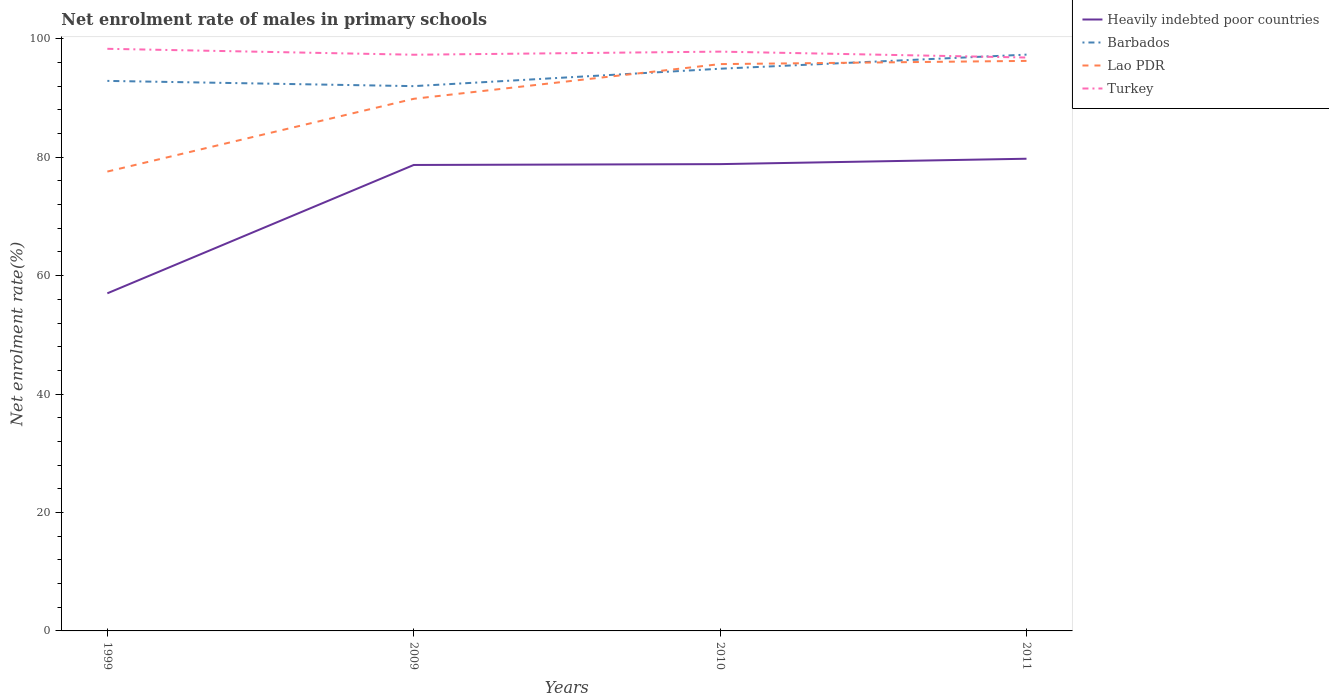How many different coloured lines are there?
Give a very brief answer. 4. Is the number of lines equal to the number of legend labels?
Your response must be concise. Yes. Across all years, what is the maximum net enrolment rate of males in primary schools in Lao PDR?
Provide a short and direct response. 77.58. What is the total net enrolment rate of males in primary schools in Heavily indebted poor countries in the graph?
Offer a terse response. -21.68. What is the difference between the highest and the second highest net enrolment rate of males in primary schools in Lao PDR?
Offer a terse response. 18.69. What is the difference between the highest and the lowest net enrolment rate of males in primary schools in Heavily indebted poor countries?
Offer a terse response. 3. Is the net enrolment rate of males in primary schools in Heavily indebted poor countries strictly greater than the net enrolment rate of males in primary schools in Barbados over the years?
Offer a terse response. Yes. How many lines are there?
Ensure brevity in your answer.  4. How many years are there in the graph?
Offer a terse response. 4. What is the difference between two consecutive major ticks on the Y-axis?
Offer a terse response. 20. Does the graph contain any zero values?
Offer a very short reply. No. Does the graph contain grids?
Provide a short and direct response. No. Where does the legend appear in the graph?
Ensure brevity in your answer.  Top right. How many legend labels are there?
Keep it short and to the point. 4. How are the legend labels stacked?
Offer a very short reply. Vertical. What is the title of the graph?
Provide a short and direct response. Net enrolment rate of males in primary schools. What is the label or title of the X-axis?
Provide a short and direct response. Years. What is the label or title of the Y-axis?
Your response must be concise. Net enrolment rate(%). What is the Net enrolment rate(%) in Heavily indebted poor countries in 1999?
Offer a terse response. 57.02. What is the Net enrolment rate(%) in Barbados in 1999?
Keep it short and to the point. 92.9. What is the Net enrolment rate(%) of Lao PDR in 1999?
Your response must be concise. 77.58. What is the Net enrolment rate(%) of Turkey in 1999?
Your answer should be compact. 98.32. What is the Net enrolment rate(%) in Heavily indebted poor countries in 2009?
Make the answer very short. 78.7. What is the Net enrolment rate(%) of Barbados in 2009?
Provide a succinct answer. 92.01. What is the Net enrolment rate(%) in Lao PDR in 2009?
Make the answer very short. 89.87. What is the Net enrolment rate(%) of Turkey in 2009?
Offer a terse response. 97.31. What is the Net enrolment rate(%) of Heavily indebted poor countries in 2010?
Ensure brevity in your answer.  78.84. What is the Net enrolment rate(%) in Barbados in 2010?
Ensure brevity in your answer.  94.95. What is the Net enrolment rate(%) in Lao PDR in 2010?
Your answer should be very brief. 95.73. What is the Net enrolment rate(%) in Turkey in 2010?
Give a very brief answer. 97.84. What is the Net enrolment rate(%) in Heavily indebted poor countries in 2011?
Your answer should be compact. 79.75. What is the Net enrolment rate(%) in Barbados in 2011?
Your answer should be very brief. 97.33. What is the Net enrolment rate(%) in Lao PDR in 2011?
Provide a succinct answer. 96.27. What is the Net enrolment rate(%) of Turkey in 2011?
Your answer should be compact. 96.84. Across all years, what is the maximum Net enrolment rate(%) in Heavily indebted poor countries?
Ensure brevity in your answer.  79.75. Across all years, what is the maximum Net enrolment rate(%) in Barbados?
Your answer should be very brief. 97.33. Across all years, what is the maximum Net enrolment rate(%) in Lao PDR?
Keep it short and to the point. 96.27. Across all years, what is the maximum Net enrolment rate(%) in Turkey?
Your response must be concise. 98.32. Across all years, what is the minimum Net enrolment rate(%) in Heavily indebted poor countries?
Give a very brief answer. 57.02. Across all years, what is the minimum Net enrolment rate(%) in Barbados?
Make the answer very short. 92.01. Across all years, what is the minimum Net enrolment rate(%) in Lao PDR?
Offer a terse response. 77.58. Across all years, what is the minimum Net enrolment rate(%) in Turkey?
Make the answer very short. 96.84. What is the total Net enrolment rate(%) of Heavily indebted poor countries in the graph?
Provide a short and direct response. 294.3. What is the total Net enrolment rate(%) in Barbados in the graph?
Offer a terse response. 377.19. What is the total Net enrolment rate(%) of Lao PDR in the graph?
Offer a very short reply. 359.46. What is the total Net enrolment rate(%) of Turkey in the graph?
Offer a terse response. 390.31. What is the difference between the Net enrolment rate(%) of Heavily indebted poor countries in 1999 and that in 2009?
Your answer should be compact. -21.68. What is the difference between the Net enrolment rate(%) in Barbados in 1999 and that in 2009?
Give a very brief answer. 0.89. What is the difference between the Net enrolment rate(%) of Lao PDR in 1999 and that in 2009?
Provide a succinct answer. -12.29. What is the difference between the Net enrolment rate(%) of Heavily indebted poor countries in 1999 and that in 2010?
Your answer should be very brief. -21.82. What is the difference between the Net enrolment rate(%) of Barbados in 1999 and that in 2010?
Provide a short and direct response. -2.05. What is the difference between the Net enrolment rate(%) of Lao PDR in 1999 and that in 2010?
Provide a short and direct response. -18.15. What is the difference between the Net enrolment rate(%) of Turkey in 1999 and that in 2010?
Provide a short and direct response. 0.48. What is the difference between the Net enrolment rate(%) in Heavily indebted poor countries in 1999 and that in 2011?
Your answer should be very brief. -22.73. What is the difference between the Net enrolment rate(%) in Barbados in 1999 and that in 2011?
Keep it short and to the point. -4.44. What is the difference between the Net enrolment rate(%) of Lao PDR in 1999 and that in 2011?
Your answer should be very brief. -18.69. What is the difference between the Net enrolment rate(%) of Turkey in 1999 and that in 2011?
Keep it short and to the point. 1.47. What is the difference between the Net enrolment rate(%) in Heavily indebted poor countries in 2009 and that in 2010?
Keep it short and to the point. -0.14. What is the difference between the Net enrolment rate(%) in Barbados in 2009 and that in 2010?
Make the answer very short. -2.94. What is the difference between the Net enrolment rate(%) in Lao PDR in 2009 and that in 2010?
Your answer should be very brief. -5.86. What is the difference between the Net enrolment rate(%) of Turkey in 2009 and that in 2010?
Offer a very short reply. -0.53. What is the difference between the Net enrolment rate(%) in Heavily indebted poor countries in 2009 and that in 2011?
Your answer should be compact. -1.05. What is the difference between the Net enrolment rate(%) in Barbados in 2009 and that in 2011?
Offer a terse response. -5.32. What is the difference between the Net enrolment rate(%) in Lao PDR in 2009 and that in 2011?
Your answer should be compact. -6.4. What is the difference between the Net enrolment rate(%) of Turkey in 2009 and that in 2011?
Give a very brief answer. 0.47. What is the difference between the Net enrolment rate(%) of Heavily indebted poor countries in 2010 and that in 2011?
Your answer should be compact. -0.91. What is the difference between the Net enrolment rate(%) in Barbados in 2010 and that in 2011?
Offer a terse response. -2.38. What is the difference between the Net enrolment rate(%) in Lao PDR in 2010 and that in 2011?
Provide a succinct answer. -0.54. What is the difference between the Net enrolment rate(%) of Turkey in 2010 and that in 2011?
Make the answer very short. 1. What is the difference between the Net enrolment rate(%) of Heavily indebted poor countries in 1999 and the Net enrolment rate(%) of Barbados in 2009?
Provide a succinct answer. -34.99. What is the difference between the Net enrolment rate(%) in Heavily indebted poor countries in 1999 and the Net enrolment rate(%) in Lao PDR in 2009?
Offer a terse response. -32.85. What is the difference between the Net enrolment rate(%) in Heavily indebted poor countries in 1999 and the Net enrolment rate(%) in Turkey in 2009?
Keep it short and to the point. -40.3. What is the difference between the Net enrolment rate(%) in Barbados in 1999 and the Net enrolment rate(%) in Lao PDR in 2009?
Provide a succinct answer. 3.03. What is the difference between the Net enrolment rate(%) in Barbados in 1999 and the Net enrolment rate(%) in Turkey in 2009?
Offer a very short reply. -4.42. What is the difference between the Net enrolment rate(%) in Lao PDR in 1999 and the Net enrolment rate(%) in Turkey in 2009?
Give a very brief answer. -19.73. What is the difference between the Net enrolment rate(%) of Heavily indebted poor countries in 1999 and the Net enrolment rate(%) of Barbados in 2010?
Provide a succinct answer. -37.93. What is the difference between the Net enrolment rate(%) of Heavily indebted poor countries in 1999 and the Net enrolment rate(%) of Lao PDR in 2010?
Keep it short and to the point. -38.71. What is the difference between the Net enrolment rate(%) of Heavily indebted poor countries in 1999 and the Net enrolment rate(%) of Turkey in 2010?
Keep it short and to the point. -40.82. What is the difference between the Net enrolment rate(%) of Barbados in 1999 and the Net enrolment rate(%) of Lao PDR in 2010?
Ensure brevity in your answer.  -2.84. What is the difference between the Net enrolment rate(%) of Barbados in 1999 and the Net enrolment rate(%) of Turkey in 2010?
Make the answer very short. -4.94. What is the difference between the Net enrolment rate(%) of Lao PDR in 1999 and the Net enrolment rate(%) of Turkey in 2010?
Give a very brief answer. -20.26. What is the difference between the Net enrolment rate(%) of Heavily indebted poor countries in 1999 and the Net enrolment rate(%) of Barbados in 2011?
Make the answer very short. -40.31. What is the difference between the Net enrolment rate(%) in Heavily indebted poor countries in 1999 and the Net enrolment rate(%) in Lao PDR in 2011?
Offer a very short reply. -39.25. What is the difference between the Net enrolment rate(%) of Heavily indebted poor countries in 1999 and the Net enrolment rate(%) of Turkey in 2011?
Keep it short and to the point. -39.82. What is the difference between the Net enrolment rate(%) in Barbados in 1999 and the Net enrolment rate(%) in Lao PDR in 2011?
Provide a short and direct response. -3.38. What is the difference between the Net enrolment rate(%) of Barbados in 1999 and the Net enrolment rate(%) of Turkey in 2011?
Offer a terse response. -3.95. What is the difference between the Net enrolment rate(%) in Lao PDR in 1999 and the Net enrolment rate(%) in Turkey in 2011?
Provide a short and direct response. -19.26. What is the difference between the Net enrolment rate(%) in Heavily indebted poor countries in 2009 and the Net enrolment rate(%) in Barbados in 2010?
Your answer should be compact. -16.25. What is the difference between the Net enrolment rate(%) in Heavily indebted poor countries in 2009 and the Net enrolment rate(%) in Lao PDR in 2010?
Provide a short and direct response. -17.04. What is the difference between the Net enrolment rate(%) of Heavily indebted poor countries in 2009 and the Net enrolment rate(%) of Turkey in 2010?
Your response must be concise. -19.14. What is the difference between the Net enrolment rate(%) in Barbados in 2009 and the Net enrolment rate(%) in Lao PDR in 2010?
Offer a terse response. -3.72. What is the difference between the Net enrolment rate(%) of Barbados in 2009 and the Net enrolment rate(%) of Turkey in 2010?
Make the answer very short. -5.83. What is the difference between the Net enrolment rate(%) in Lao PDR in 2009 and the Net enrolment rate(%) in Turkey in 2010?
Your answer should be very brief. -7.97. What is the difference between the Net enrolment rate(%) in Heavily indebted poor countries in 2009 and the Net enrolment rate(%) in Barbados in 2011?
Give a very brief answer. -18.64. What is the difference between the Net enrolment rate(%) of Heavily indebted poor countries in 2009 and the Net enrolment rate(%) of Lao PDR in 2011?
Provide a short and direct response. -17.58. What is the difference between the Net enrolment rate(%) in Heavily indebted poor countries in 2009 and the Net enrolment rate(%) in Turkey in 2011?
Provide a short and direct response. -18.15. What is the difference between the Net enrolment rate(%) in Barbados in 2009 and the Net enrolment rate(%) in Lao PDR in 2011?
Provide a succinct answer. -4.26. What is the difference between the Net enrolment rate(%) of Barbados in 2009 and the Net enrolment rate(%) of Turkey in 2011?
Offer a very short reply. -4.83. What is the difference between the Net enrolment rate(%) of Lao PDR in 2009 and the Net enrolment rate(%) of Turkey in 2011?
Provide a succinct answer. -6.97. What is the difference between the Net enrolment rate(%) of Heavily indebted poor countries in 2010 and the Net enrolment rate(%) of Barbados in 2011?
Offer a terse response. -18.49. What is the difference between the Net enrolment rate(%) of Heavily indebted poor countries in 2010 and the Net enrolment rate(%) of Lao PDR in 2011?
Provide a short and direct response. -17.43. What is the difference between the Net enrolment rate(%) of Heavily indebted poor countries in 2010 and the Net enrolment rate(%) of Turkey in 2011?
Provide a succinct answer. -18. What is the difference between the Net enrolment rate(%) of Barbados in 2010 and the Net enrolment rate(%) of Lao PDR in 2011?
Your answer should be very brief. -1.32. What is the difference between the Net enrolment rate(%) in Barbados in 2010 and the Net enrolment rate(%) in Turkey in 2011?
Give a very brief answer. -1.89. What is the difference between the Net enrolment rate(%) of Lao PDR in 2010 and the Net enrolment rate(%) of Turkey in 2011?
Your answer should be very brief. -1.11. What is the average Net enrolment rate(%) in Heavily indebted poor countries per year?
Give a very brief answer. 73.58. What is the average Net enrolment rate(%) in Barbados per year?
Offer a very short reply. 94.3. What is the average Net enrolment rate(%) of Lao PDR per year?
Your response must be concise. 89.86. What is the average Net enrolment rate(%) of Turkey per year?
Offer a very short reply. 97.58. In the year 1999, what is the difference between the Net enrolment rate(%) of Heavily indebted poor countries and Net enrolment rate(%) of Barbados?
Make the answer very short. -35.88. In the year 1999, what is the difference between the Net enrolment rate(%) in Heavily indebted poor countries and Net enrolment rate(%) in Lao PDR?
Your response must be concise. -20.56. In the year 1999, what is the difference between the Net enrolment rate(%) in Heavily indebted poor countries and Net enrolment rate(%) in Turkey?
Keep it short and to the point. -41.3. In the year 1999, what is the difference between the Net enrolment rate(%) in Barbados and Net enrolment rate(%) in Lao PDR?
Ensure brevity in your answer.  15.31. In the year 1999, what is the difference between the Net enrolment rate(%) in Barbados and Net enrolment rate(%) in Turkey?
Offer a very short reply. -5.42. In the year 1999, what is the difference between the Net enrolment rate(%) of Lao PDR and Net enrolment rate(%) of Turkey?
Your answer should be very brief. -20.73. In the year 2009, what is the difference between the Net enrolment rate(%) in Heavily indebted poor countries and Net enrolment rate(%) in Barbados?
Provide a short and direct response. -13.31. In the year 2009, what is the difference between the Net enrolment rate(%) in Heavily indebted poor countries and Net enrolment rate(%) in Lao PDR?
Keep it short and to the point. -11.17. In the year 2009, what is the difference between the Net enrolment rate(%) in Heavily indebted poor countries and Net enrolment rate(%) in Turkey?
Offer a terse response. -18.62. In the year 2009, what is the difference between the Net enrolment rate(%) of Barbados and Net enrolment rate(%) of Lao PDR?
Your answer should be very brief. 2.14. In the year 2009, what is the difference between the Net enrolment rate(%) of Barbados and Net enrolment rate(%) of Turkey?
Your answer should be very brief. -5.3. In the year 2009, what is the difference between the Net enrolment rate(%) in Lao PDR and Net enrolment rate(%) in Turkey?
Your response must be concise. -7.44. In the year 2010, what is the difference between the Net enrolment rate(%) of Heavily indebted poor countries and Net enrolment rate(%) of Barbados?
Offer a very short reply. -16.11. In the year 2010, what is the difference between the Net enrolment rate(%) in Heavily indebted poor countries and Net enrolment rate(%) in Lao PDR?
Provide a succinct answer. -16.89. In the year 2010, what is the difference between the Net enrolment rate(%) in Heavily indebted poor countries and Net enrolment rate(%) in Turkey?
Offer a terse response. -19. In the year 2010, what is the difference between the Net enrolment rate(%) in Barbados and Net enrolment rate(%) in Lao PDR?
Your response must be concise. -0.78. In the year 2010, what is the difference between the Net enrolment rate(%) of Barbados and Net enrolment rate(%) of Turkey?
Ensure brevity in your answer.  -2.89. In the year 2010, what is the difference between the Net enrolment rate(%) of Lao PDR and Net enrolment rate(%) of Turkey?
Your response must be concise. -2.11. In the year 2011, what is the difference between the Net enrolment rate(%) in Heavily indebted poor countries and Net enrolment rate(%) in Barbados?
Make the answer very short. -17.58. In the year 2011, what is the difference between the Net enrolment rate(%) of Heavily indebted poor countries and Net enrolment rate(%) of Lao PDR?
Ensure brevity in your answer.  -16.52. In the year 2011, what is the difference between the Net enrolment rate(%) of Heavily indebted poor countries and Net enrolment rate(%) of Turkey?
Offer a terse response. -17.09. In the year 2011, what is the difference between the Net enrolment rate(%) in Barbados and Net enrolment rate(%) in Lao PDR?
Give a very brief answer. 1.06. In the year 2011, what is the difference between the Net enrolment rate(%) in Barbados and Net enrolment rate(%) in Turkey?
Offer a terse response. 0.49. In the year 2011, what is the difference between the Net enrolment rate(%) of Lao PDR and Net enrolment rate(%) of Turkey?
Your answer should be compact. -0.57. What is the ratio of the Net enrolment rate(%) in Heavily indebted poor countries in 1999 to that in 2009?
Provide a short and direct response. 0.72. What is the ratio of the Net enrolment rate(%) of Barbados in 1999 to that in 2009?
Offer a terse response. 1.01. What is the ratio of the Net enrolment rate(%) of Lao PDR in 1999 to that in 2009?
Your answer should be very brief. 0.86. What is the ratio of the Net enrolment rate(%) in Turkey in 1999 to that in 2009?
Ensure brevity in your answer.  1.01. What is the ratio of the Net enrolment rate(%) in Heavily indebted poor countries in 1999 to that in 2010?
Make the answer very short. 0.72. What is the ratio of the Net enrolment rate(%) of Barbados in 1999 to that in 2010?
Provide a short and direct response. 0.98. What is the ratio of the Net enrolment rate(%) in Lao PDR in 1999 to that in 2010?
Ensure brevity in your answer.  0.81. What is the ratio of the Net enrolment rate(%) in Heavily indebted poor countries in 1999 to that in 2011?
Make the answer very short. 0.71. What is the ratio of the Net enrolment rate(%) in Barbados in 1999 to that in 2011?
Provide a succinct answer. 0.95. What is the ratio of the Net enrolment rate(%) in Lao PDR in 1999 to that in 2011?
Provide a short and direct response. 0.81. What is the ratio of the Net enrolment rate(%) of Turkey in 1999 to that in 2011?
Provide a succinct answer. 1.02. What is the ratio of the Net enrolment rate(%) of Barbados in 2009 to that in 2010?
Your response must be concise. 0.97. What is the ratio of the Net enrolment rate(%) in Lao PDR in 2009 to that in 2010?
Give a very brief answer. 0.94. What is the ratio of the Net enrolment rate(%) in Turkey in 2009 to that in 2010?
Your answer should be compact. 0.99. What is the ratio of the Net enrolment rate(%) in Heavily indebted poor countries in 2009 to that in 2011?
Your response must be concise. 0.99. What is the ratio of the Net enrolment rate(%) of Barbados in 2009 to that in 2011?
Your response must be concise. 0.95. What is the ratio of the Net enrolment rate(%) of Lao PDR in 2009 to that in 2011?
Make the answer very short. 0.93. What is the ratio of the Net enrolment rate(%) of Heavily indebted poor countries in 2010 to that in 2011?
Offer a very short reply. 0.99. What is the ratio of the Net enrolment rate(%) of Barbados in 2010 to that in 2011?
Your answer should be compact. 0.98. What is the ratio of the Net enrolment rate(%) of Turkey in 2010 to that in 2011?
Your answer should be very brief. 1.01. What is the difference between the highest and the second highest Net enrolment rate(%) in Heavily indebted poor countries?
Offer a terse response. 0.91. What is the difference between the highest and the second highest Net enrolment rate(%) in Barbados?
Your response must be concise. 2.38. What is the difference between the highest and the second highest Net enrolment rate(%) of Lao PDR?
Give a very brief answer. 0.54. What is the difference between the highest and the second highest Net enrolment rate(%) of Turkey?
Provide a short and direct response. 0.48. What is the difference between the highest and the lowest Net enrolment rate(%) of Heavily indebted poor countries?
Provide a short and direct response. 22.73. What is the difference between the highest and the lowest Net enrolment rate(%) in Barbados?
Your answer should be very brief. 5.32. What is the difference between the highest and the lowest Net enrolment rate(%) of Lao PDR?
Offer a very short reply. 18.69. What is the difference between the highest and the lowest Net enrolment rate(%) of Turkey?
Make the answer very short. 1.47. 